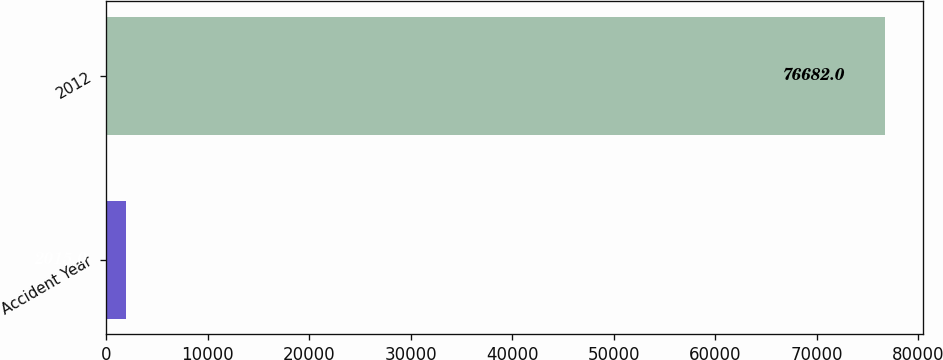<chart> <loc_0><loc_0><loc_500><loc_500><bar_chart><fcel>Accident Year<fcel>2012<nl><fcel>2015<fcel>76682<nl></chart> 